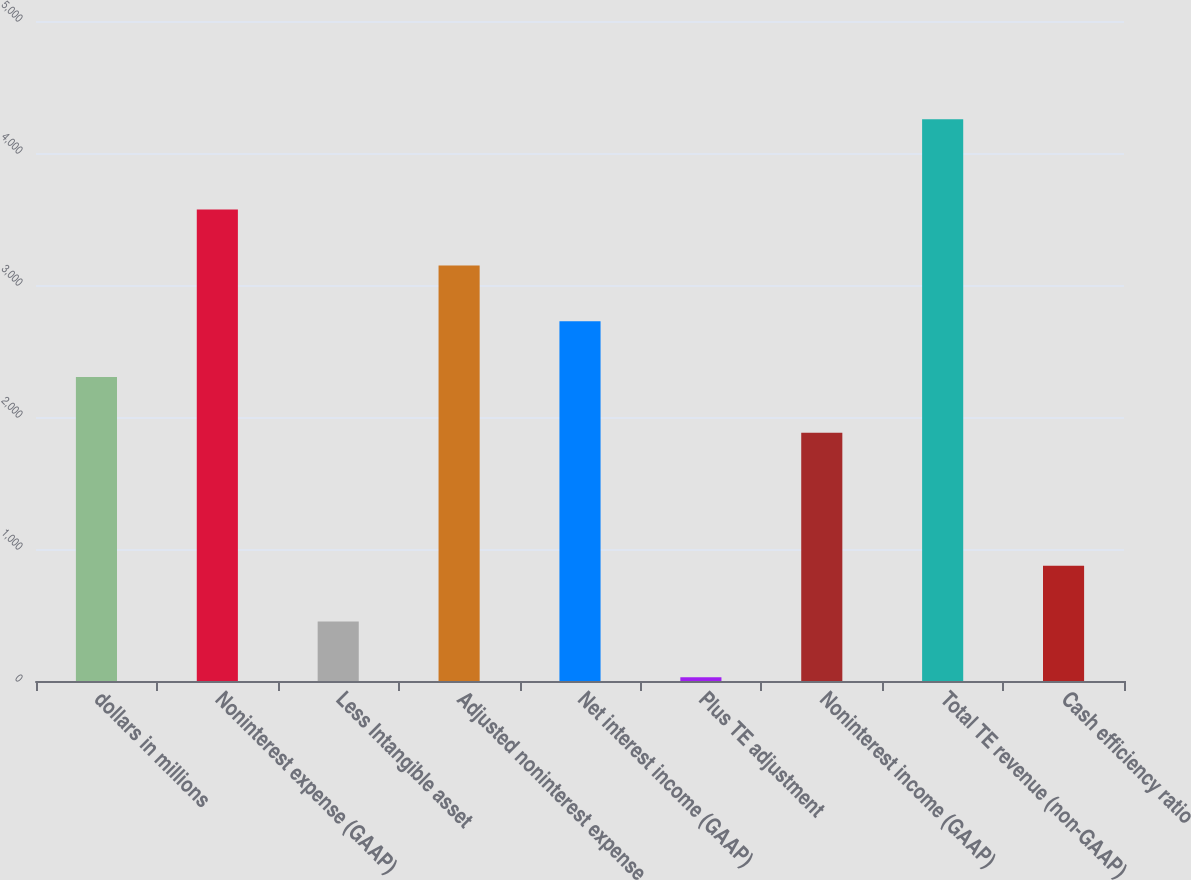Convert chart. <chart><loc_0><loc_0><loc_500><loc_500><bar_chart><fcel>dollars in millions<fcel>Noninterest expense (GAAP)<fcel>Less Intangible asset<fcel>Adjusted noninterest expense<fcel>Net interest income (GAAP)<fcel>Plus TE adjustment<fcel>Noninterest income (GAAP)<fcel>Total TE revenue (non-GAAP)<fcel>Cash efficiency ratio<nl><fcel>2302.8<fcel>3571.2<fcel>450.8<fcel>3148.4<fcel>2725.6<fcel>28<fcel>1880<fcel>4256<fcel>873.6<nl></chart> 